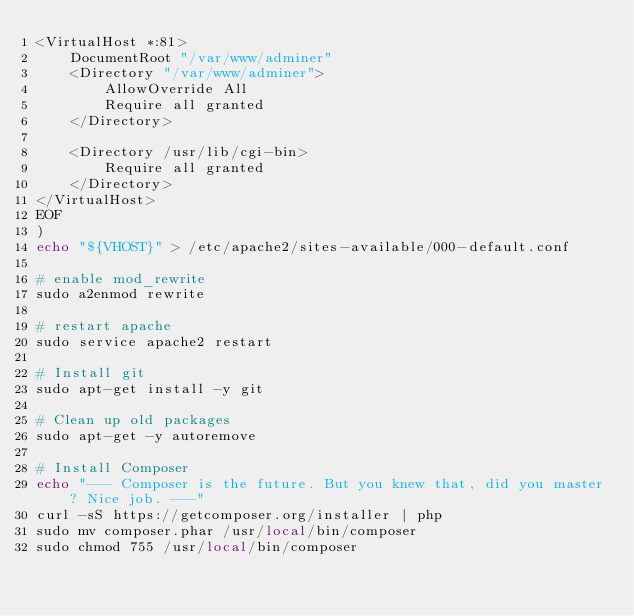Convert code to text. <code><loc_0><loc_0><loc_500><loc_500><_Bash_><VirtualHost *:81>
    DocumentRoot "/var/www/adminer"
    <Directory "/var/www/adminer">
        AllowOverride All
        Require all granted
    </Directory>

    <Directory /usr/lib/cgi-bin>
        Require all granted
    </Directory>
</VirtualHost>
EOF
)
echo "${VHOST}" > /etc/apache2/sites-available/000-default.conf

# enable mod_rewrite
sudo a2enmod rewrite

# restart apache
sudo service apache2 restart

# Install git
sudo apt-get install -y git

# Clean up old packages
sudo apt-get -y autoremove

# Install Composer
echo "--- Composer is the future. But you knew that, did you master? Nice job. ---"
curl -sS https://getcomposer.org/installer | php
sudo mv composer.phar /usr/local/bin/composer
sudo chmod 755 /usr/local/bin/composer
</code> 